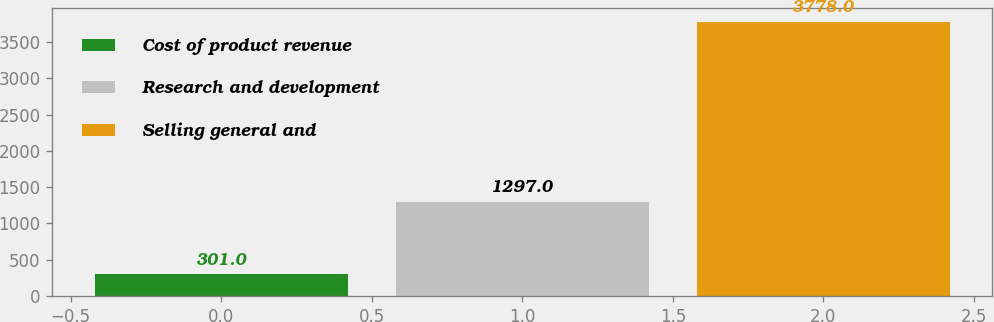<chart> <loc_0><loc_0><loc_500><loc_500><bar_chart><fcel>Cost of product revenue<fcel>Research and development<fcel>Selling general and<nl><fcel>301<fcel>1297<fcel>3778<nl></chart> 